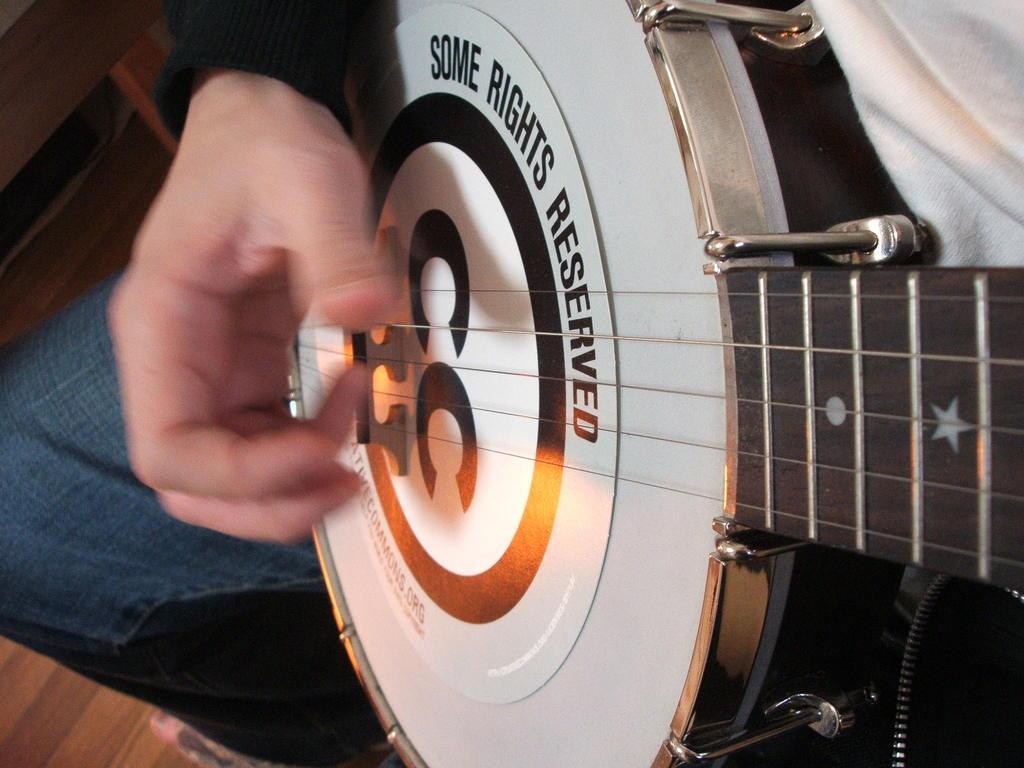Could you give a brief overview of what you see in this image? In the image we can see there is a person who is holding guitar in his hand. 